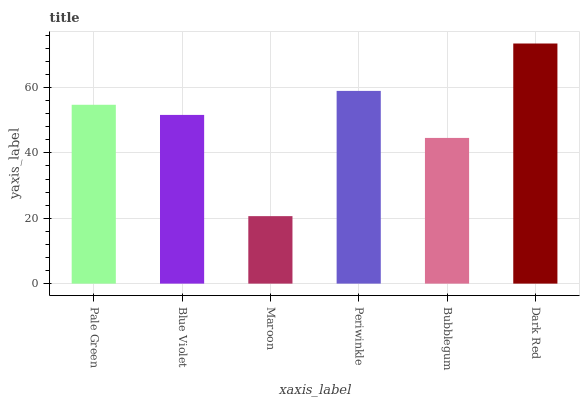Is Maroon the minimum?
Answer yes or no. Yes. Is Dark Red the maximum?
Answer yes or no. Yes. Is Blue Violet the minimum?
Answer yes or no. No. Is Blue Violet the maximum?
Answer yes or no. No. Is Pale Green greater than Blue Violet?
Answer yes or no. Yes. Is Blue Violet less than Pale Green?
Answer yes or no. Yes. Is Blue Violet greater than Pale Green?
Answer yes or no. No. Is Pale Green less than Blue Violet?
Answer yes or no. No. Is Pale Green the high median?
Answer yes or no. Yes. Is Blue Violet the low median?
Answer yes or no. Yes. Is Periwinkle the high median?
Answer yes or no. No. Is Pale Green the low median?
Answer yes or no. No. 